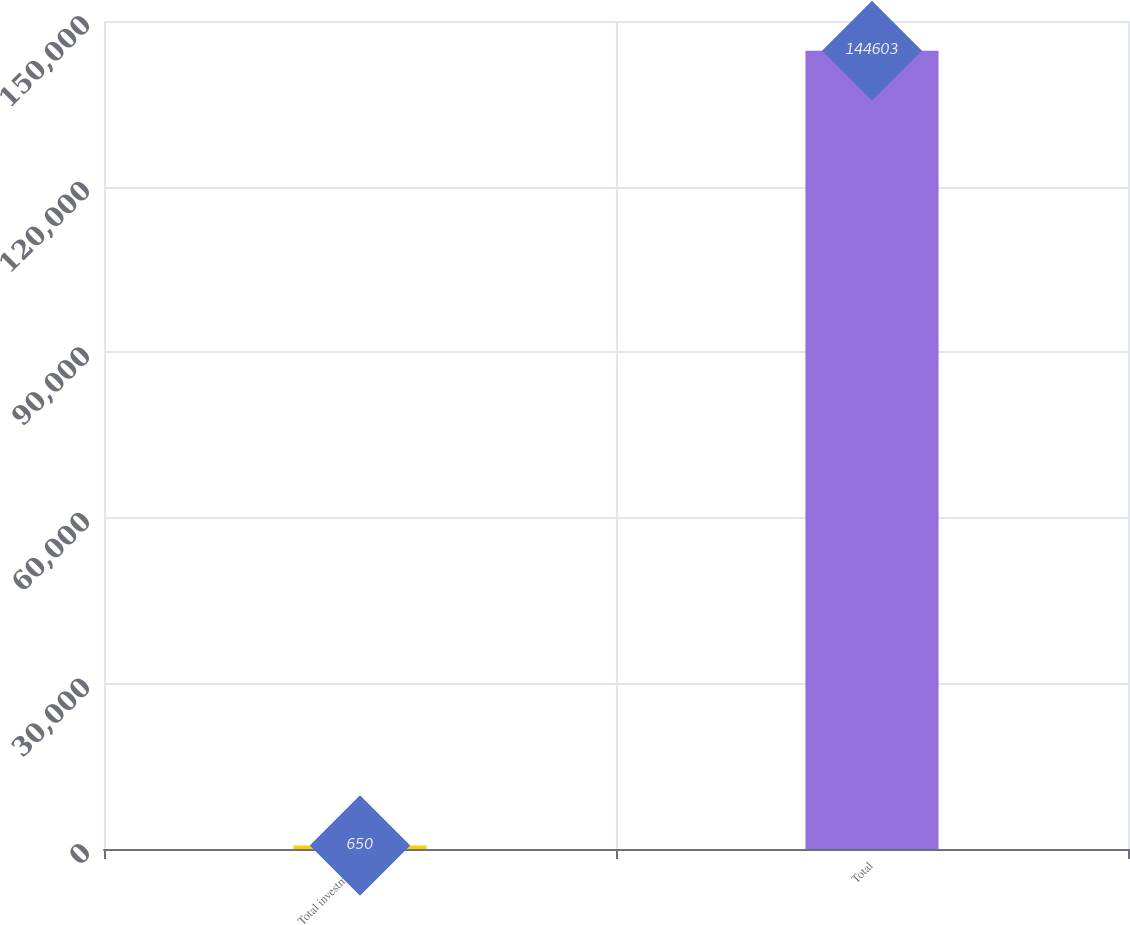<chart> <loc_0><loc_0><loc_500><loc_500><bar_chart><fcel>Total investments<fcel>Total<nl><fcel>650<fcel>144603<nl></chart> 